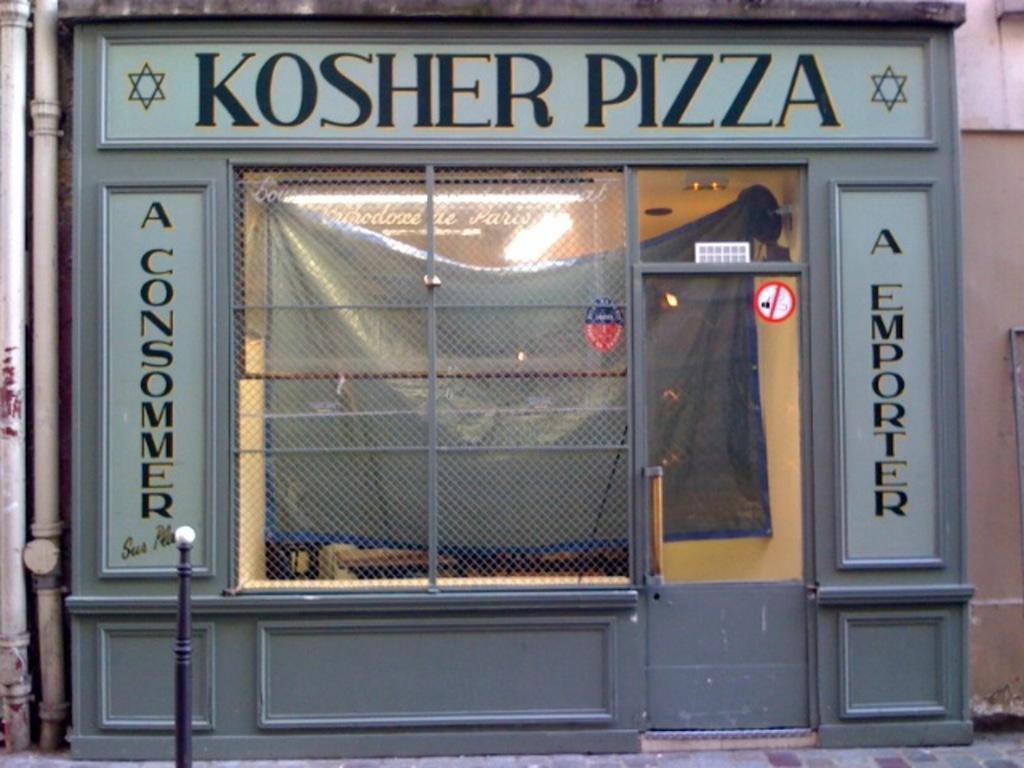Could you give a brief overview of what you see in this image? In this image, it seems like a store on which there is a door and text, it seems like a wall on the right side and there are pipes and a small pole on the left side. 